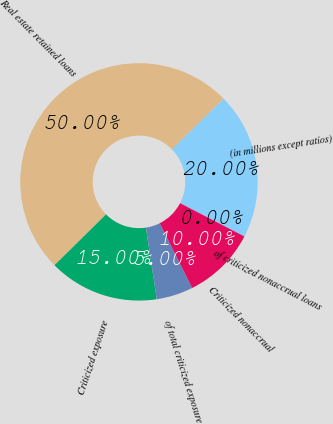Convert chart. <chart><loc_0><loc_0><loc_500><loc_500><pie_chart><fcel>(in millions except ratios)<fcel>Real estate retained loans<fcel>Criticized exposure<fcel>of total criticized exposure<fcel>Criticized nonaccrual<fcel>of criticized nonaccrual loans<nl><fcel>20.0%<fcel>50.0%<fcel>15.0%<fcel>5.0%<fcel>10.0%<fcel>0.0%<nl></chart> 